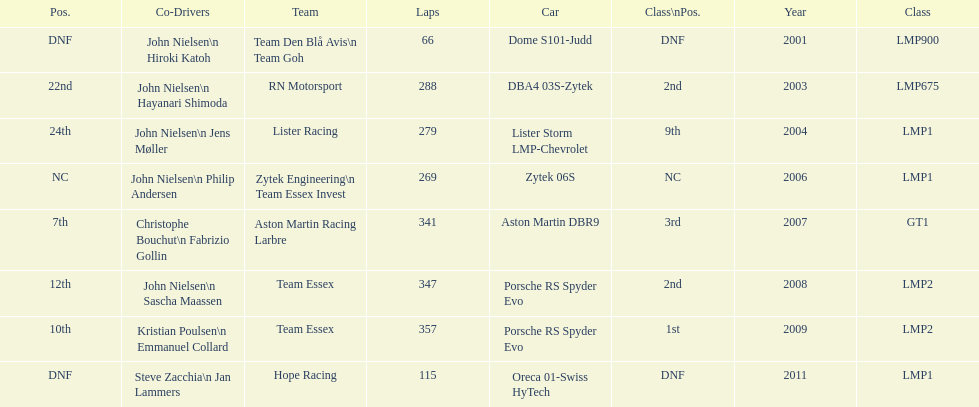Who was casper elgaard's co-driver the most often for the 24 hours of le mans? John Nielsen. 